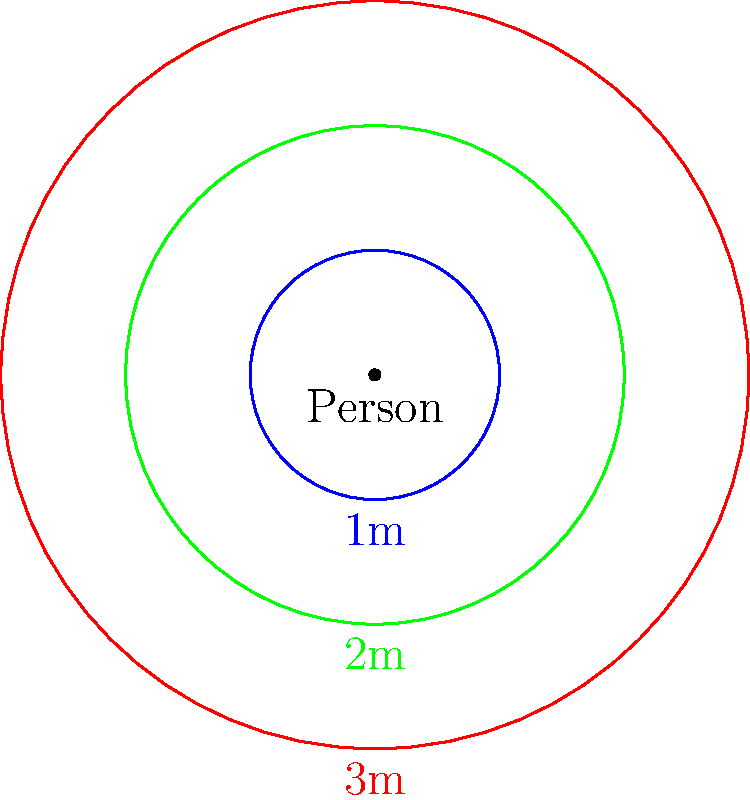In the diagram above, concentric circles represent different social distancing radii around a person. If the probability of disease transmission decreases exponentially with distance, and the transmission probability at 1m is 0.8, at 2m is 0.3, and at 3m is 0.1, what is the approximate rate of decay ($\lambda$) in the exponential function $P(d) = e^{-\lambda d}$, where $P(d)$ is the probability of transmission at distance $d$? To solve this problem, we'll use the exponential decay function $P(d) = e^{-\lambda d}$ and the given probabilities at different distances:

1) At 1m: $P(1) = 0.8 = e^{-\lambda \cdot 1}$
2) At 2m: $P(2) = 0.3 = e^{-\lambda \cdot 2}$
3) At 3m: $P(3) = 0.1 = e^{-\lambda \cdot 3}$

We can use any two of these equations to solve for $\lambda$. Let's use the 1m and 3m data points:

4) Taking natural log of both sides:
   $\ln(0.8) = -\lambda \cdot 1$ and $\ln(0.1) = -\lambda \cdot 3$

5) Subtracting these equations:
   $\ln(0.8) - \ln(0.1) = -\lambda \cdot 1 - (-\lambda \cdot 3) = 2\lambda$

6) Solving for $\lambda$:
   $\lambda = \frac{\ln(0.8) - \ln(0.1)}{2} = \frac{\ln(8)}{2} \approx 1.04$

7) We can verify this value using the 2m data point:
   $e^{-1.04 \cdot 2} \approx 0.3$, which matches the given probability.
Answer: $\lambda \approx 1.04$ 